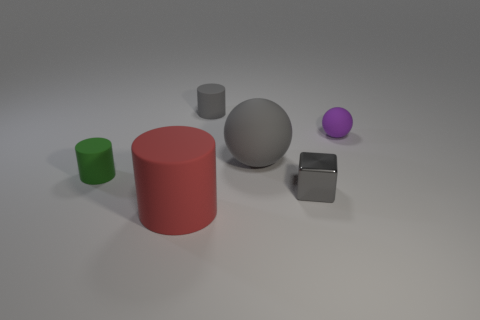Add 2 large yellow metallic cylinders. How many objects exist? 8 Subtract all cubes. How many objects are left? 5 Subtract all tiny purple spheres. Subtract all purple rubber balls. How many objects are left? 4 Add 6 big red matte cylinders. How many big red matte cylinders are left? 7 Add 5 big balls. How many big balls exist? 6 Subtract 0 green cubes. How many objects are left? 6 